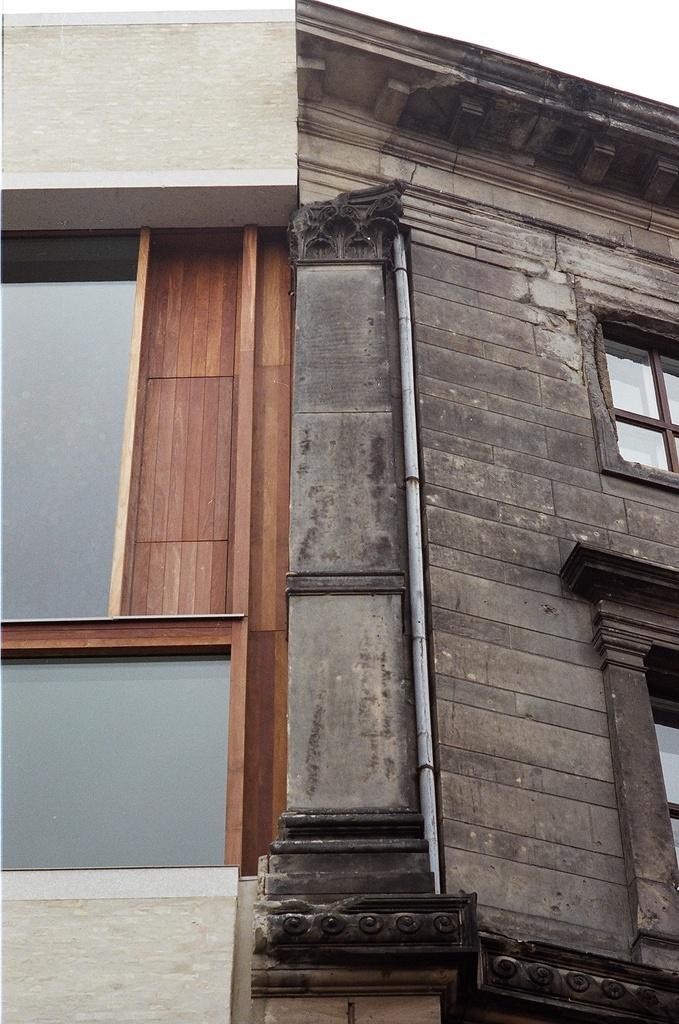How would you summarize this image in a sentence or two? In the image we can see a building and these are the windows of the building, and a sky. 